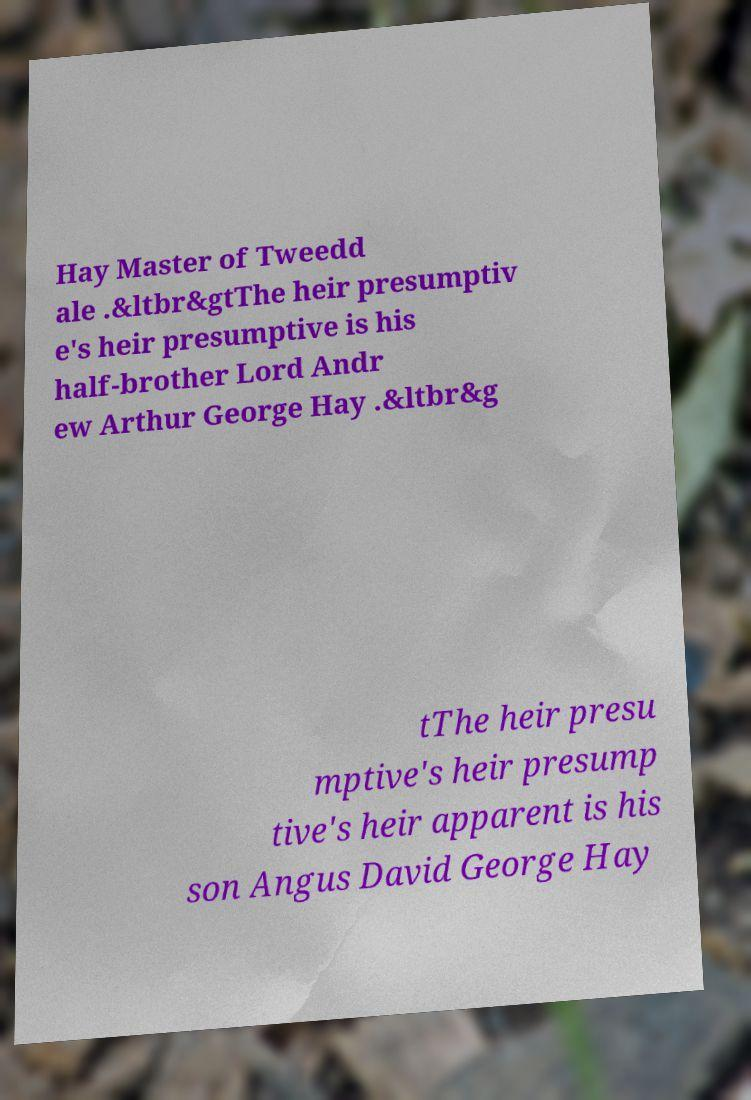Please read and relay the text visible in this image. What does it say? Hay Master of Tweedd ale .&ltbr&gtThe heir presumptiv e's heir presumptive is his half-brother Lord Andr ew Arthur George Hay .&ltbr&g tThe heir presu mptive's heir presump tive's heir apparent is his son Angus David George Hay 